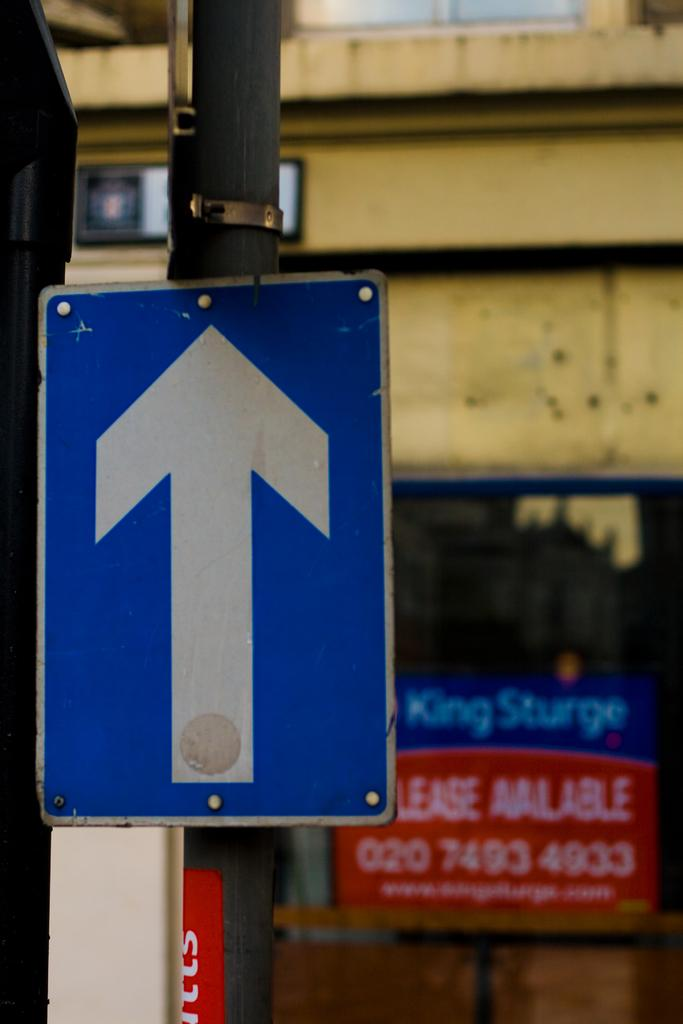Provide a one-sentence caption for the provided image. A sign with an arrow pointing forward in front of a building that is available for lease. 